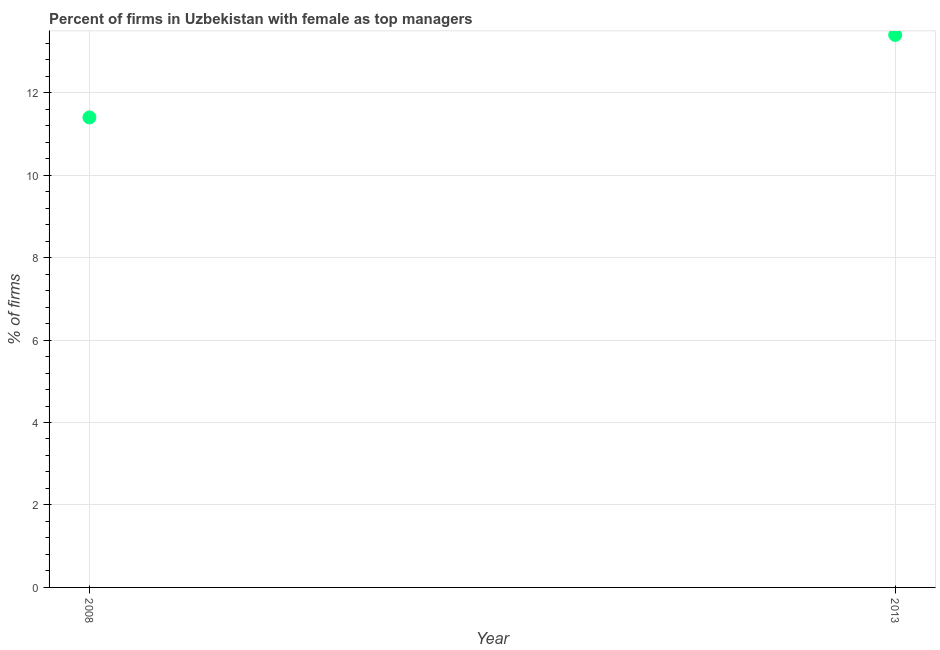What is the percentage of firms with female as top manager in 2008?
Your answer should be compact. 11.4. What is the sum of the percentage of firms with female as top manager?
Make the answer very short. 24.8. What is the difference between the percentage of firms with female as top manager in 2008 and 2013?
Offer a very short reply. -2. What is the average percentage of firms with female as top manager per year?
Ensure brevity in your answer.  12.4. What is the ratio of the percentage of firms with female as top manager in 2008 to that in 2013?
Your answer should be very brief. 0.85. In how many years, is the percentage of firms with female as top manager greater than the average percentage of firms with female as top manager taken over all years?
Offer a very short reply. 1. How many dotlines are there?
Make the answer very short. 1. What is the difference between two consecutive major ticks on the Y-axis?
Your answer should be compact. 2. Are the values on the major ticks of Y-axis written in scientific E-notation?
Make the answer very short. No. Does the graph contain grids?
Make the answer very short. Yes. What is the title of the graph?
Your response must be concise. Percent of firms in Uzbekistan with female as top managers. What is the label or title of the Y-axis?
Provide a short and direct response. % of firms. What is the difference between the % of firms in 2008 and 2013?
Give a very brief answer. -2. What is the ratio of the % of firms in 2008 to that in 2013?
Offer a terse response. 0.85. 